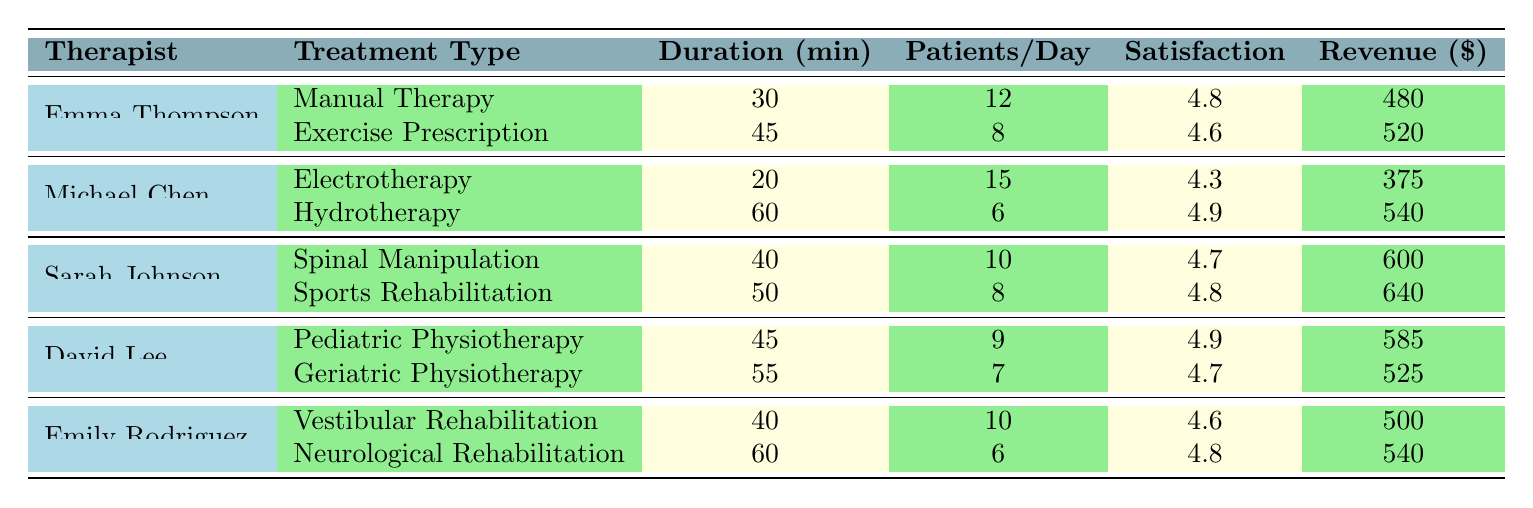What is the appointment duration for Sarah Johnson's Spinal Manipulation treatment? The table shows that for the treatment type "Spinal Manipulation" provided by Sarah Johnson, the appointment duration is listed as 40 minutes.
Answer: 40 How many patients does Michael Chen see per day for Hydrotherapy? According to the table, Michael Chen sees 6 patients per day for Hydrotherapy.
Answer: 6 Which therapist has the highest revenue generated from a single treatment type? By comparing the revenue figures in the table, Sarah Johnson has the highest revenue of 640 generated from Sports Rehabilitation.
Answer: Sarah Johnson What is the average satisfaction score across all treatment types? The satisfaction scores in the table are: 4.8, 4.6, 4.3, 4.9, 4.7, 4.8, 4.9, 4.7, 4.6, and 4.8. Summing these scores gives 47.6. Dividing by the number of treatments (10) yields an average of 4.76.
Answer: 4.76 Is David Lee's satisfaction score for Pediatric Physiotherapy higher than that for Geriatric Physiotherapy? The table shows a satisfaction score of 4.9 for Pediatric Physiotherapy and 4.7 for Geriatric Physiotherapy. Therefore, David Lee's satisfaction score for Pediatric Physiotherapy is indeed higher.
Answer: Yes How many total patients does Emma Thompson see in a day across both treatment types? Adding the patients per day from both of Emma Thompson's treatments: 12 (Manual Therapy) + 8 (Exercise Prescription) equals 20 patients total per day.
Answer: 20 Which treatment type generates the most revenue by a therapist that also has a 60-minute appointment? According to the table, the revenue for the 60-minute appointment type "Hydrotherapy" is 540, and "Neurological Rehabilitation," another 60-minute treatment, generates 540 as well. Since both generate the same, we can say both are the highest revenue generating treatments of that duration.
Answer: Hydrotherapy and Neurological Rehabilitation What is the satisfaction score for Michael Chen's Electrotherapy treatment? The table indicates that Michael Chen's satisfaction score for Electrotherapy is 4.3.
Answer: 4.3 